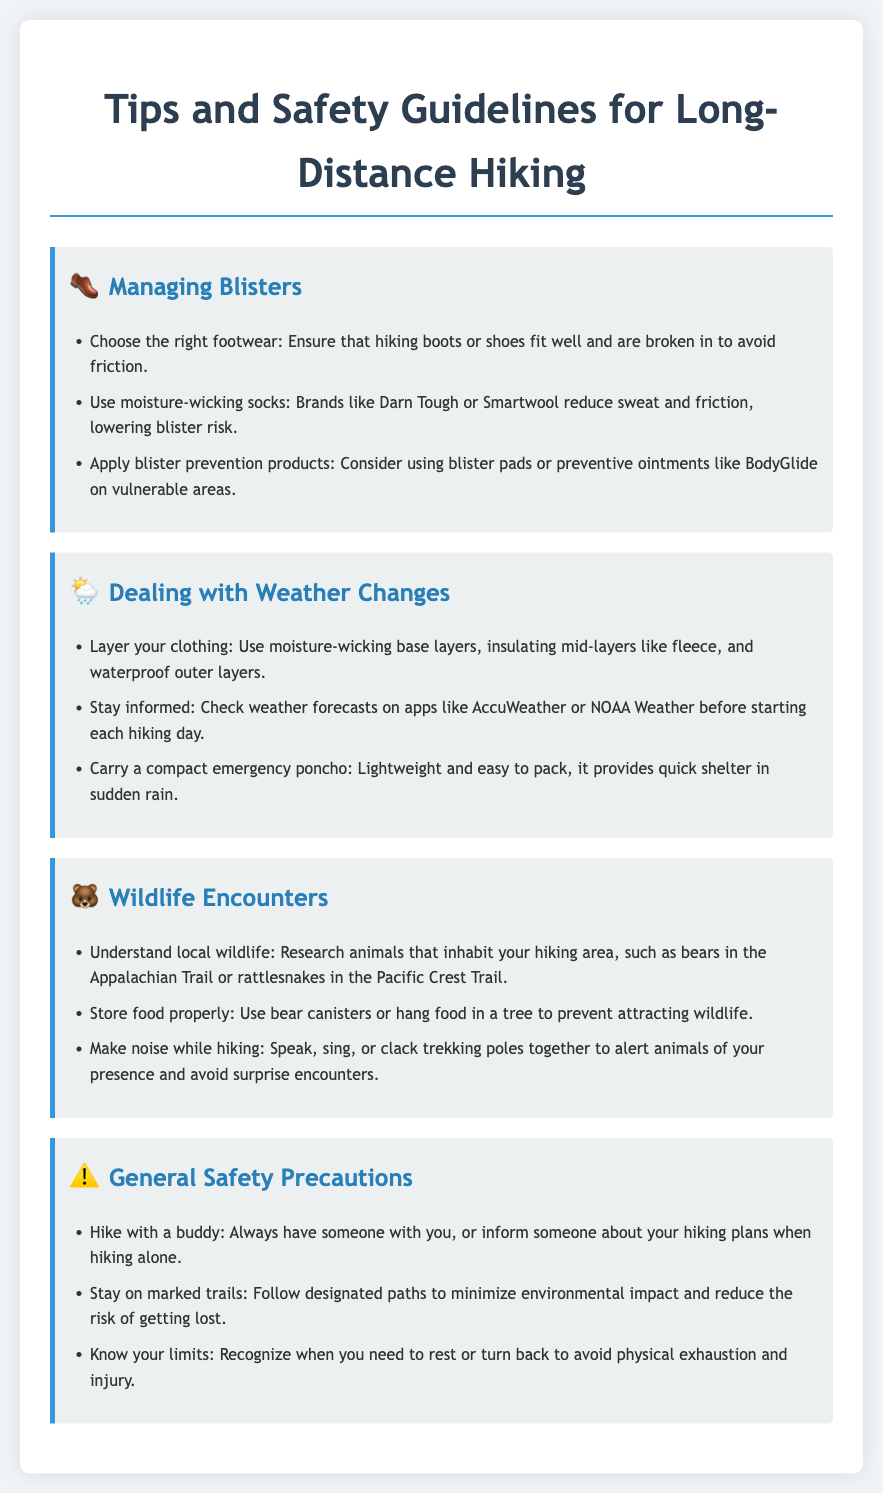What footwear is recommended to avoid blisters? The document suggests ensuring that hiking boots or shoes fit well and are broken in to avoid friction.
Answer: Properly fitting footwear What should you apply to prevent blisters? It mentions considering using blister pads or preventive ointments like BodyGlide on vulnerable areas.
Answer: Blister pads or BodyGlide What type of clothing should you layer for weather changes? The document advises using moisture-wicking base layers, insulating mid-layers like fleece, and waterproof outer layers.
Answer: Layered clothing How can you store food to prevent wildlife encounters? It suggests using bear canisters or hanging food in a tree to prevent attracting wildlife.
Answer: Bear canisters or hanging food What is a safety precaution mentioned for hiking? The document states that you should always hike with a buddy or inform someone of your plans when hiking alone.
Answer: Hike with a buddy 